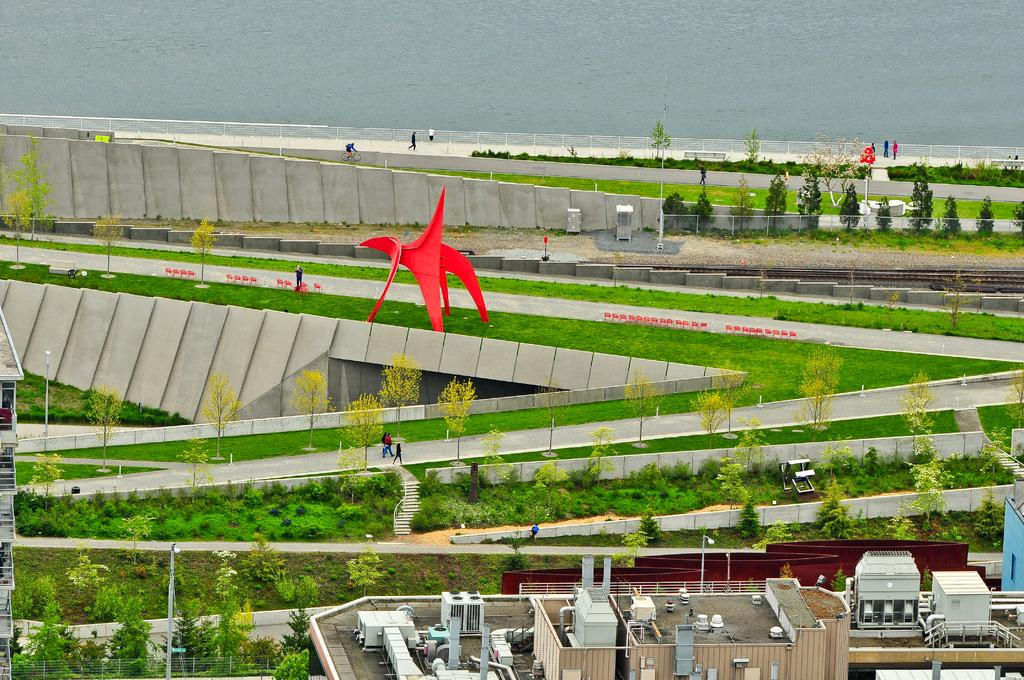What type of structures can be seen in the image? There are buildings in the image. What type of vegetation is present in the image? There are plants and trees in the image. What type of transportation infrastructure is visible in the image? There are flyovers in the image. What type of barrier is present in the image? There is a fence in the image. Are there any people visible in the image? Yes, there are people in the image. What type of architectural elements can be seen in the image? There are walls in the image. What color stands out in the image? There is a red color object in the image. What natural element is visible at the top of the image? There is water visible at the top of the image}. Where is the guide leading the meeting in the image? There is no guide or meeting present in the image. What type of unit is being discussed in the image? There is no discussion of any unit in the image. 